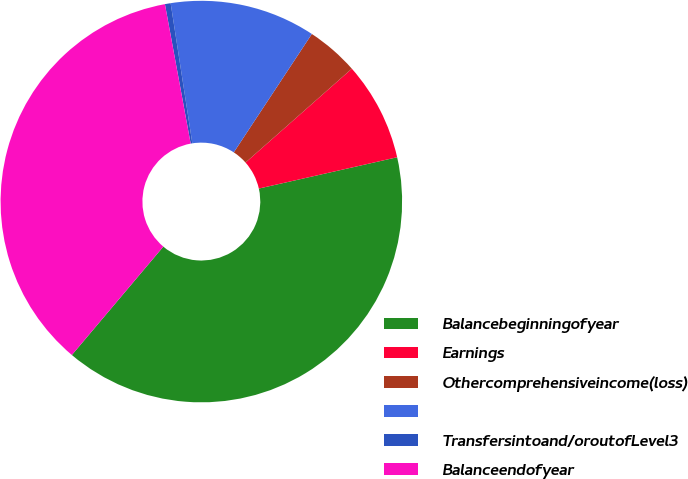Convert chart to OTSL. <chart><loc_0><loc_0><loc_500><loc_500><pie_chart><fcel>Balancebeginningofyear<fcel>Earnings<fcel>Othercomprehensiveincome(loss)<fcel>Unnamed: 3<fcel>Transfersintoand/oroutofLevel3<fcel>Balanceendofyear<nl><fcel>39.7%<fcel>7.97%<fcel>4.21%<fcel>11.72%<fcel>0.46%<fcel>35.94%<nl></chart> 